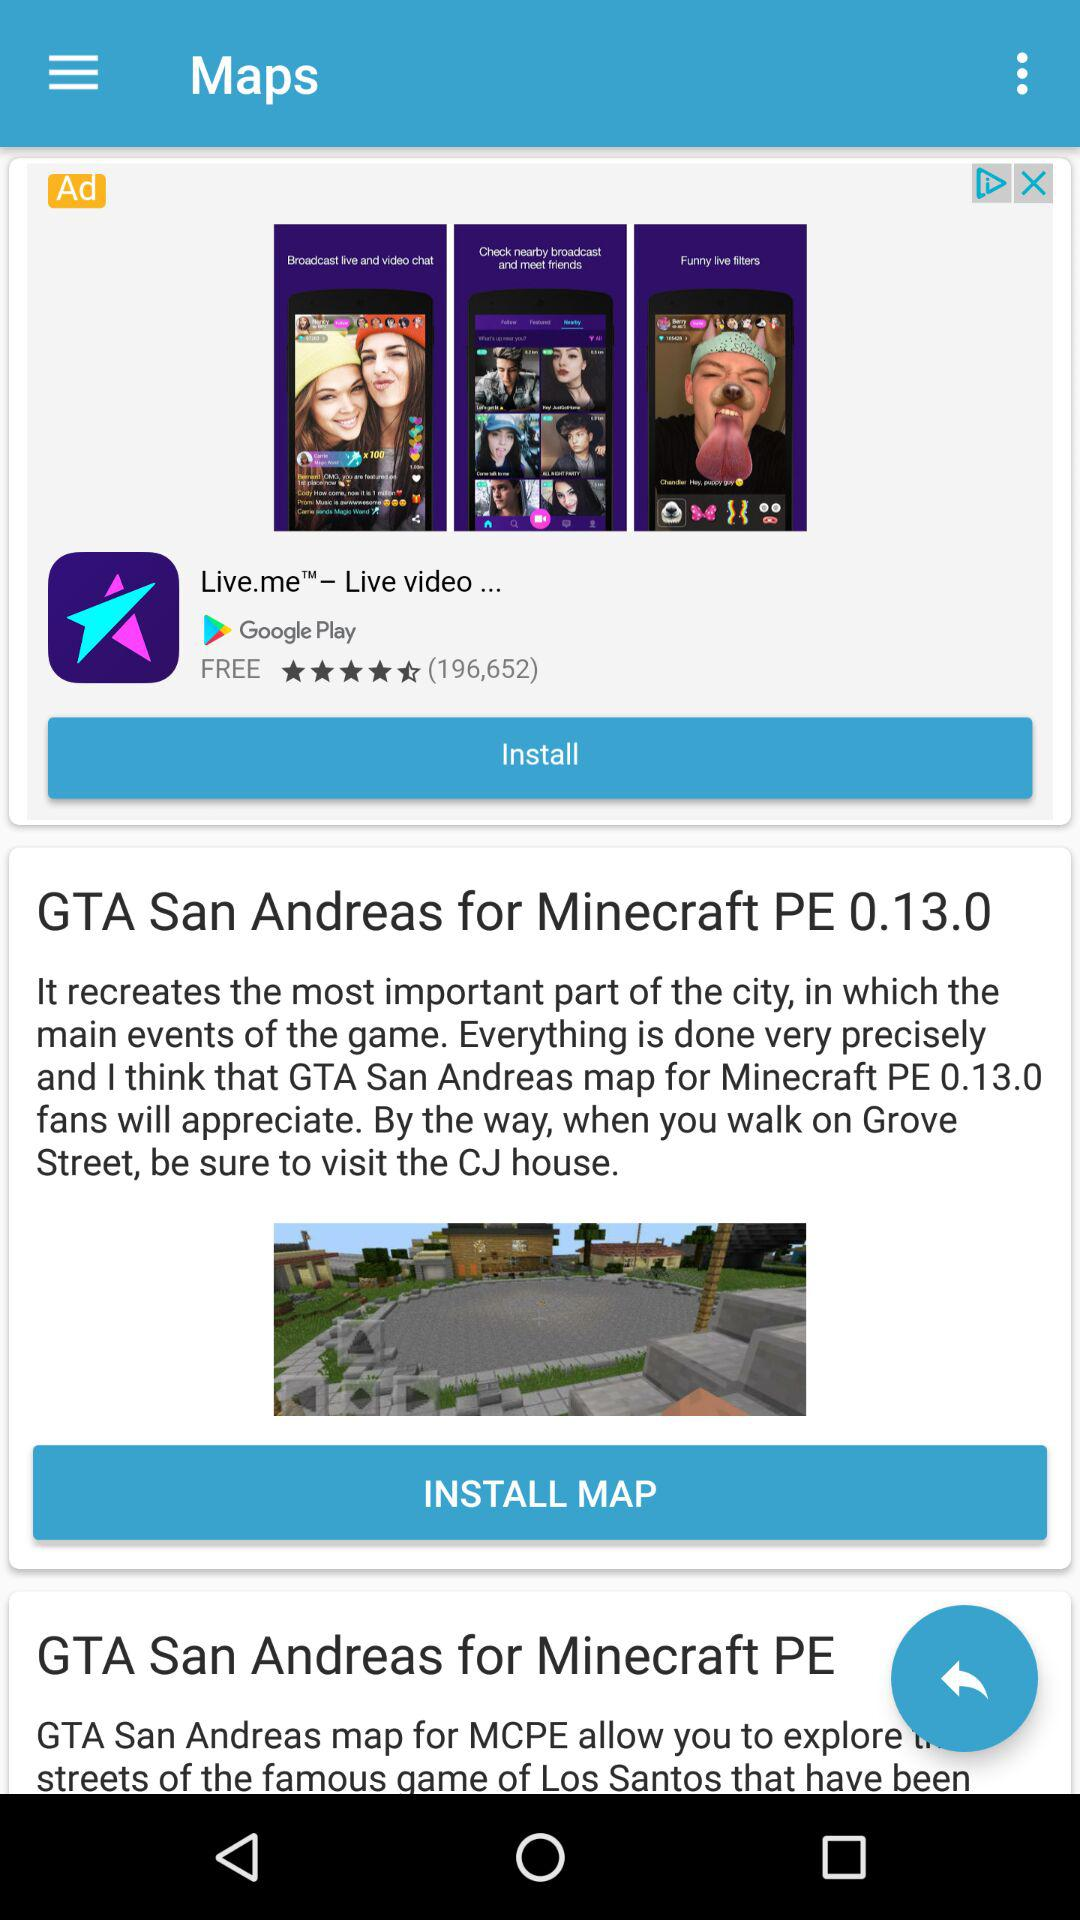What is the playable editor version of the "GTA San Andreas for Minecraft PE" game? The playable editor version is 0.13.0. 